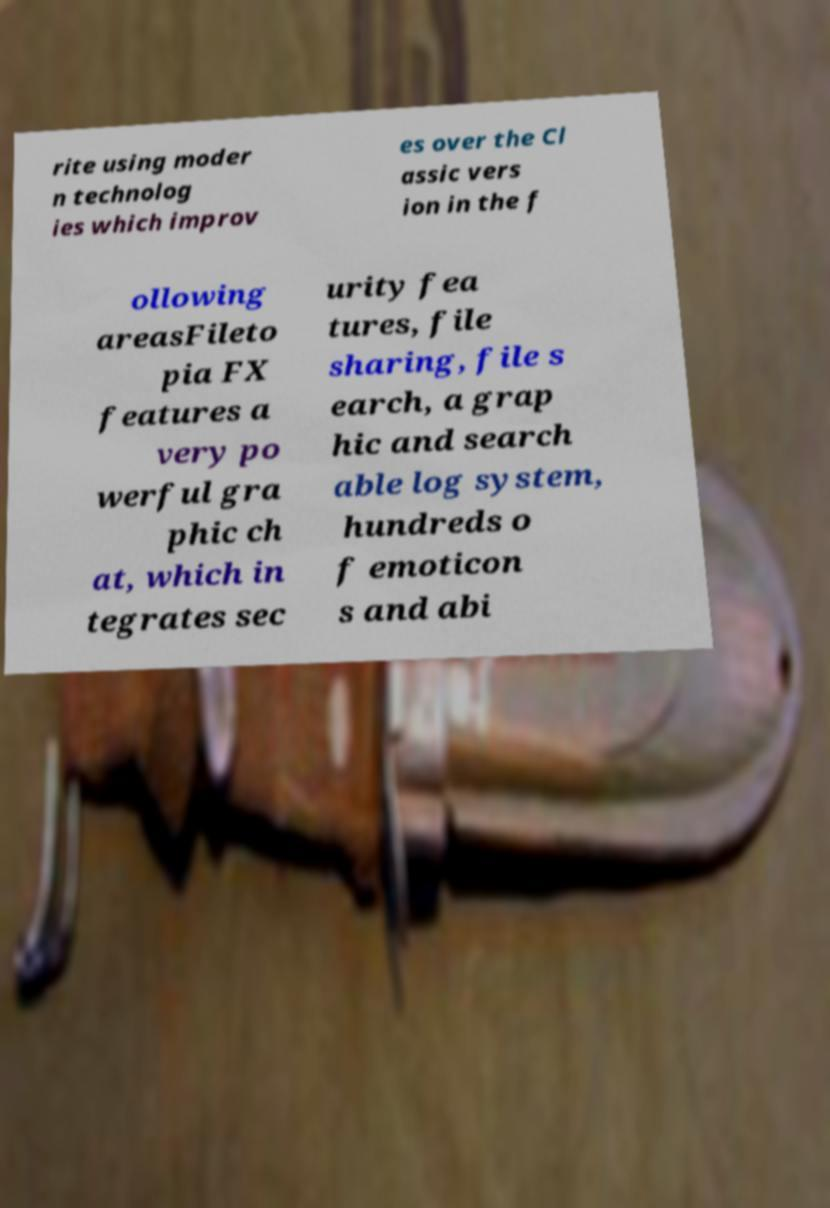Could you assist in decoding the text presented in this image and type it out clearly? rite using moder n technolog ies which improv es over the Cl assic vers ion in the f ollowing areasFileto pia FX features a very po werful gra phic ch at, which in tegrates sec urity fea tures, file sharing, file s earch, a grap hic and search able log system, hundreds o f emoticon s and abi 